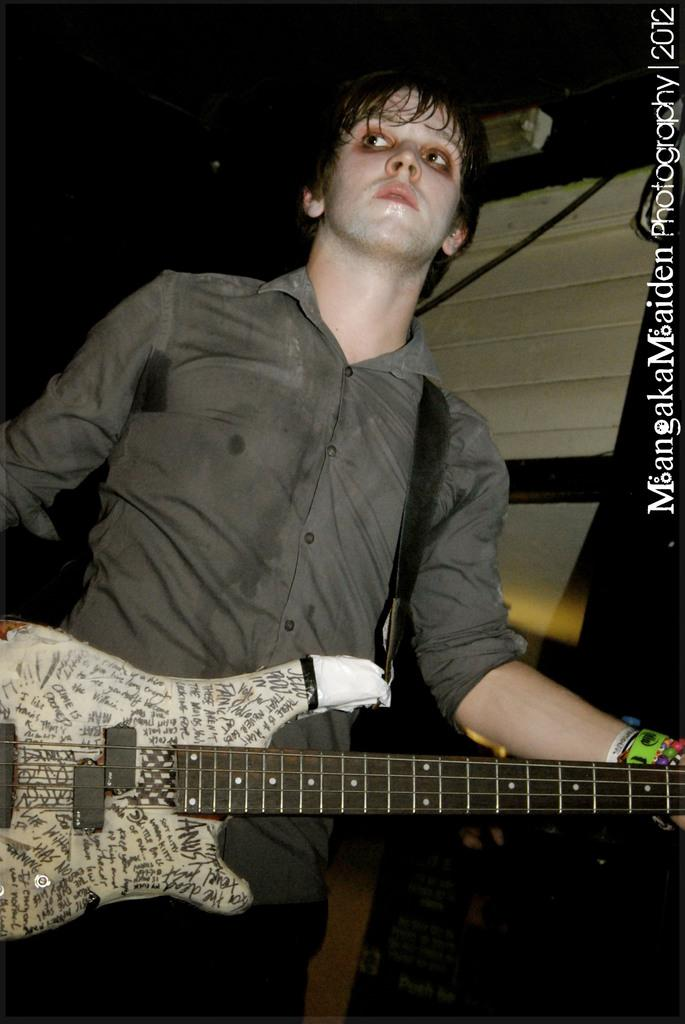What is the main subject of the image? There is a man in the image. What is the man holding in the image? The man is holding a guitar. How is the man holding the guitar? The man is holding the guitar with his hands. What type of railway can be seen in the image? There is no railway present in the image. What is the man using to mix the eggnog in the image? There is no eggnog or mixing tool present in the image. 